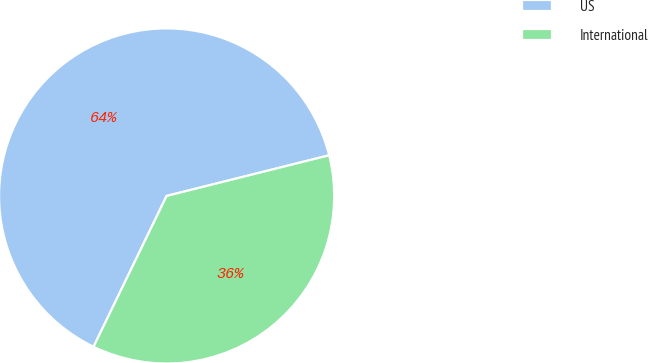Convert chart. <chart><loc_0><loc_0><loc_500><loc_500><pie_chart><fcel>US<fcel>International<nl><fcel>63.92%<fcel>36.08%<nl></chart> 